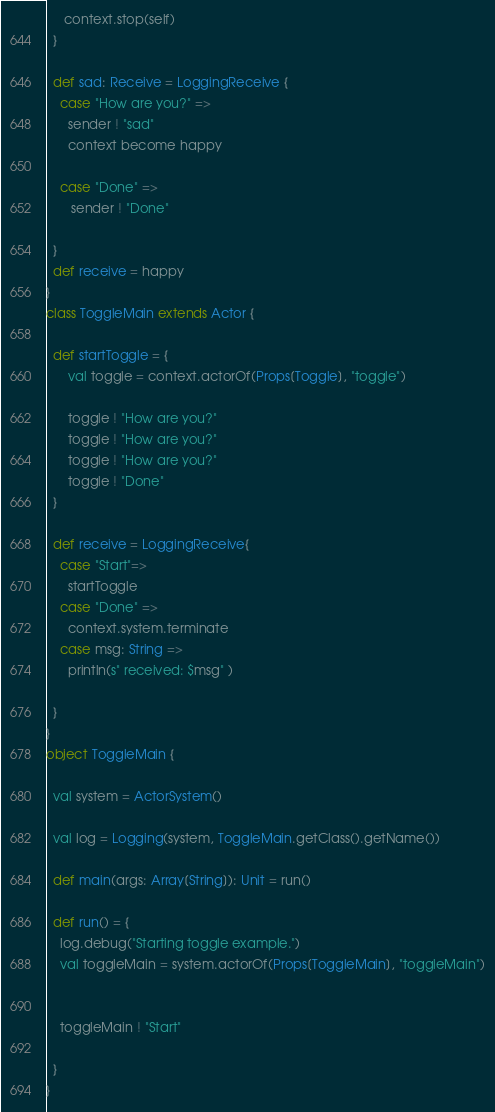Convert code to text. <code><loc_0><loc_0><loc_500><loc_500><_Scala_>     context.stop(self)
  }
  
  def sad: Receive = LoggingReceive {
    case "How are you?" =>
      sender ! "sad"
      context become happy
      
    case "Done" =>
       sender ! "Done"
   
  }
  def receive = happy
}
class ToggleMain extends Actor {
 
  def startToggle = {
	  val toggle = context.actorOf(Props[Toggle], "toggle")
 
	  toggle ! "How are you?"
      toggle ! "How are you?"
      toggle ! "How are you?"
      toggle ! "Done"
  }
  
  def receive = LoggingReceive{
    case "Start"=>
      startToggle
    case "Done" =>
      context.system.terminate
    case msg: String =>
      println(s" received: $msg" )
     
  }
}
object ToggleMain {
  
  val system = ActorSystem()
  
  val log = Logging(system, ToggleMain.getClass().getName())
  
  def main(args: Array[String]): Unit = run()
  
  def run() = {
    log.debug("Starting toggle example.")
    val toggleMain = system.actorOf(Props[ToggleMain], "toggleMain")
    
 
    toggleMain ! "Start"
 
  }
}
</code> 